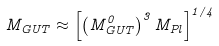Convert formula to latex. <formula><loc_0><loc_0><loc_500><loc_500>M _ { G U T } \approx \left [ \left ( M _ { G U T } ^ { 0 } \right ) ^ { 3 } M _ { P l } \right ] ^ { 1 / 4 }</formula> 